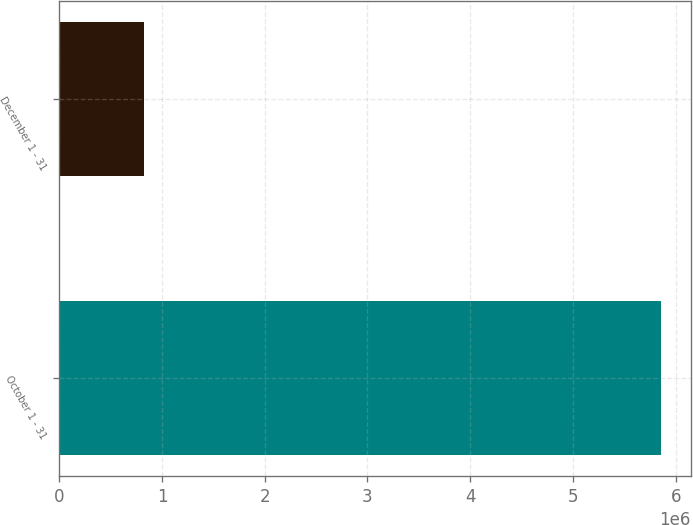Convert chart to OTSL. <chart><loc_0><loc_0><loc_500><loc_500><bar_chart><fcel>October 1 - 31<fcel>December 1 - 31<nl><fcel>5.85493e+06<fcel>826744<nl></chart> 